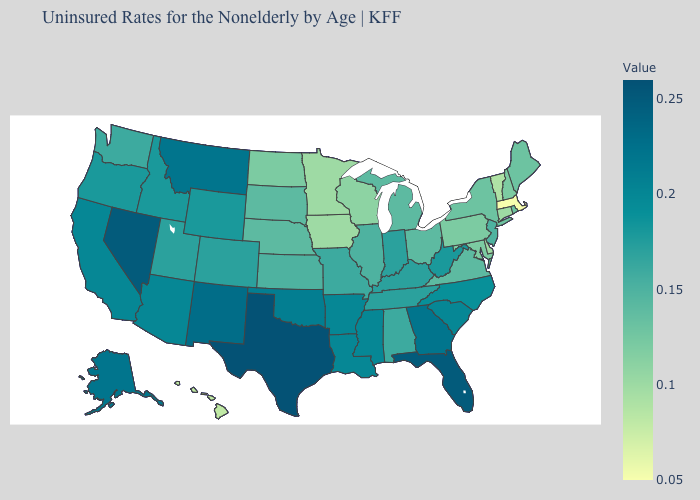Among the states that border Vermont , does Massachusetts have the lowest value?
Write a very short answer. Yes. Which states hav the highest value in the MidWest?
Write a very short answer. Indiana. Does Iowa have a higher value than Missouri?
Quick response, please. No. Does the map have missing data?
Write a very short answer. No. Among the states that border Arizona , does New Mexico have the lowest value?
Short answer required. No. Does Oregon have the highest value in the West?
Short answer required. No. 